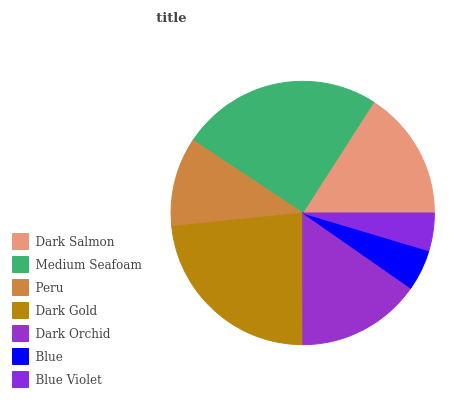Is Blue Violet the minimum?
Answer yes or no. Yes. Is Medium Seafoam the maximum?
Answer yes or no. Yes. Is Peru the minimum?
Answer yes or no. No. Is Peru the maximum?
Answer yes or no. No. Is Medium Seafoam greater than Peru?
Answer yes or no. Yes. Is Peru less than Medium Seafoam?
Answer yes or no. Yes. Is Peru greater than Medium Seafoam?
Answer yes or no. No. Is Medium Seafoam less than Peru?
Answer yes or no. No. Is Dark Orchid the high median?
Answer yes or no. Yes. Is Dark Orchid the low median?
Answer yes or no. Yes. Is Dark Salmon the high median?
Answer yes or no. No. Is Medium Seafoam the low median?
Answer yes or no. No. 